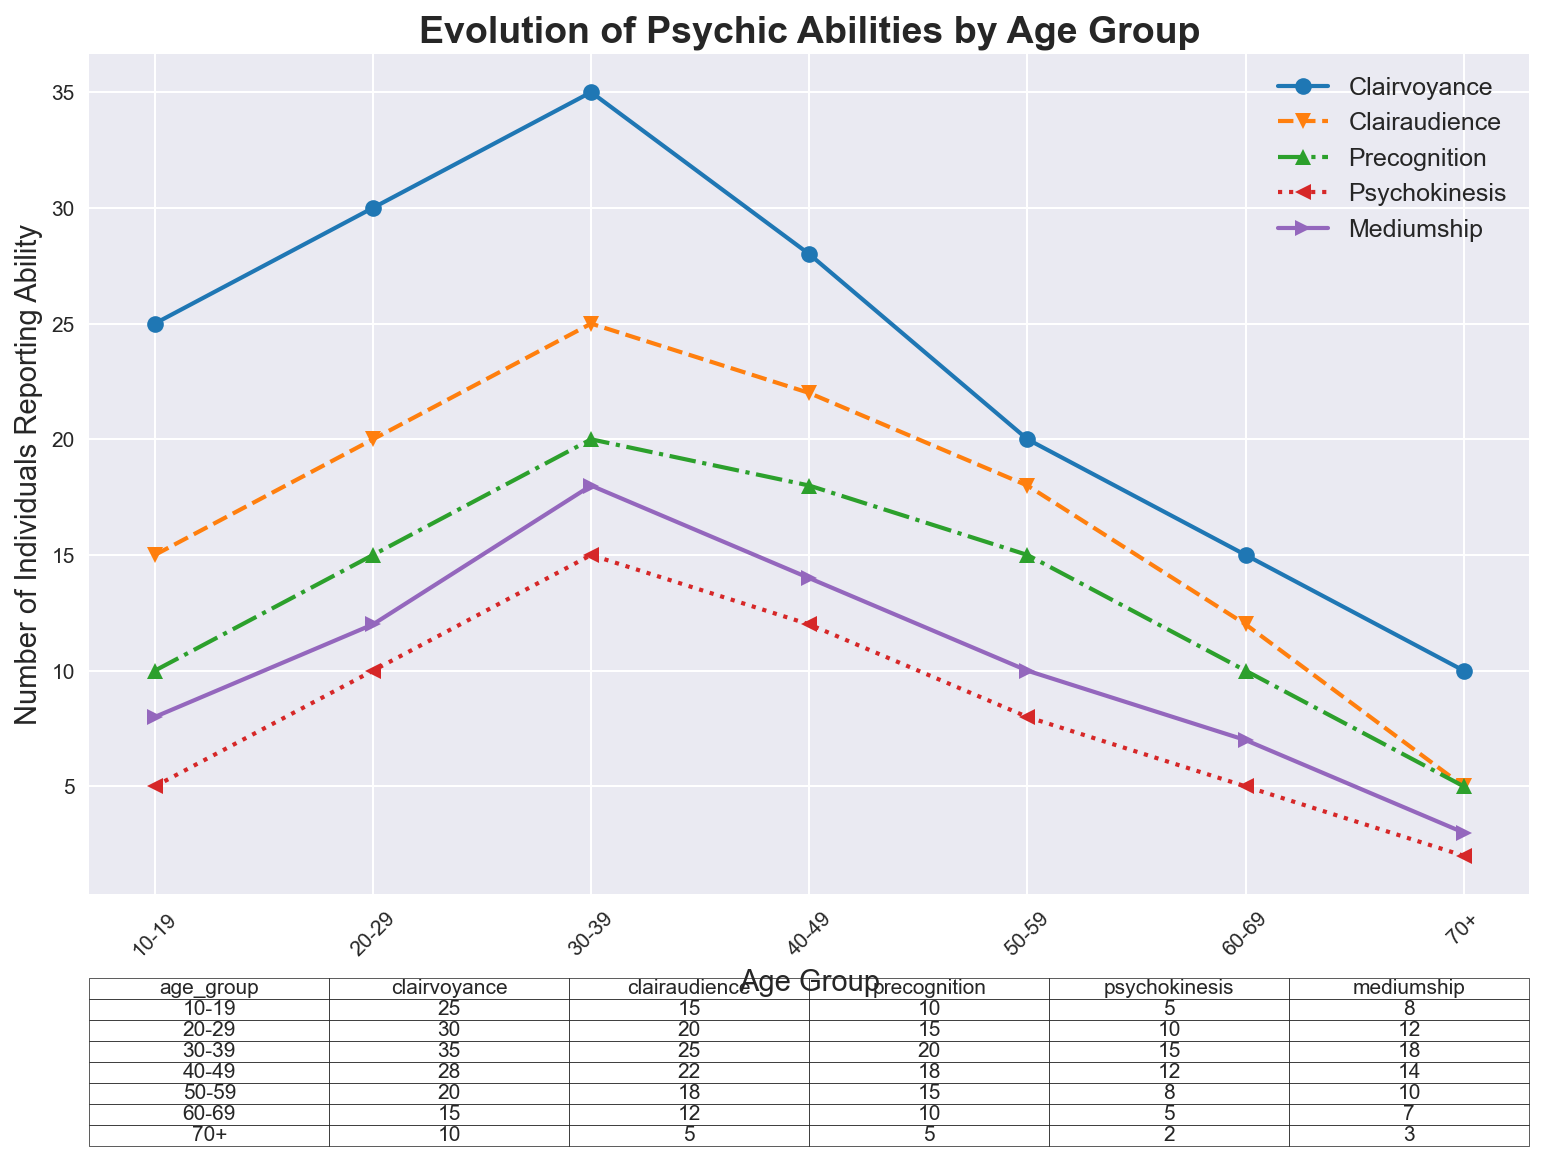What's the highest number of individuals reporting clairvoyance for any age group? The highest number reported for clairvoyance across all age groups is for the 30-39 age group, with a value of 35 individuals.
Answer: 35 Which age group has the lowest number of individuals reporting clairaudience, and what's that number? The 70+ age group has the lowest number of individuals reporting clairaudience, with a value of 5 individuals.
Answer: 70+, 5 For the age group 50-59, what's the combined number of individuals reporting precognition and psychokinesis? For the age group 50-59, the number of individuals reporting precognition is 15 and psychokinesis is 8. Adding these gives 15 + 8 = 23.
Answer: 23 Compare the number of individuals reporting mediumship in the 20-29 age group with those in the 60-69 age group. Which is higher and by how much? The 20-29 age group has 12 individuals reporting mediumship, while the 60-69 age group has 7. The difference is 12 - 7 = 5.
Answer: 20-29 by 5 What's the average number of individuals reporting psychokinesis across all age groups? Sum up the number of individuals reporting psychokinesis across all age groups (5 + 10 + 15 + 12 + 8 + 5 + 2 = 57), then divide by the number of age groups (7). The average is 57 / 7 = 8.14.
Answer: 8.14 In the 30-39 age group, what is the difference between the number of individuals reporting clairaudience and mediumship? For the 30-39 age group, the number of individuals reporting clairaudience is 25 and mediumship is 18. The difference is 25 - 18 = 7.
Answer: 7 Which psychic ability shows a decreasing trend in the number of individuals reporting it as age increases? Clairvoyance shows a decreasing trend from the 30-39 age group through to the 70+ age group.
Answer: Clairvoyance Identify the age group with the second highest number of individuals reporting precognition and provide the number. The age group 40-49 has the second highest number of individuals reporting precognition, with 18 individuals.
Answer: 40-49, 18 What is the total number of individuals reporting any psychic ability in the age group 10-19? Sum up the number of individuals reporting each psychic ability for the 10-19 age group: 25 (clairvoyance) + 15 (clairaudience) + 10 (precognition) + 5 (psychokinesis) + 8 (mediumship) = 63.
Answer: 63 Between the age groups 10-19 and 60-69, which group has more individuals reporting clairaudience and by how much? For the age group 10-19, 15 individuals report clairaudience, and for the age group 60-69, 12 individuals report clairaudience. The difference is 15 - 12 = 3.
Answer: 10-19 by 3 